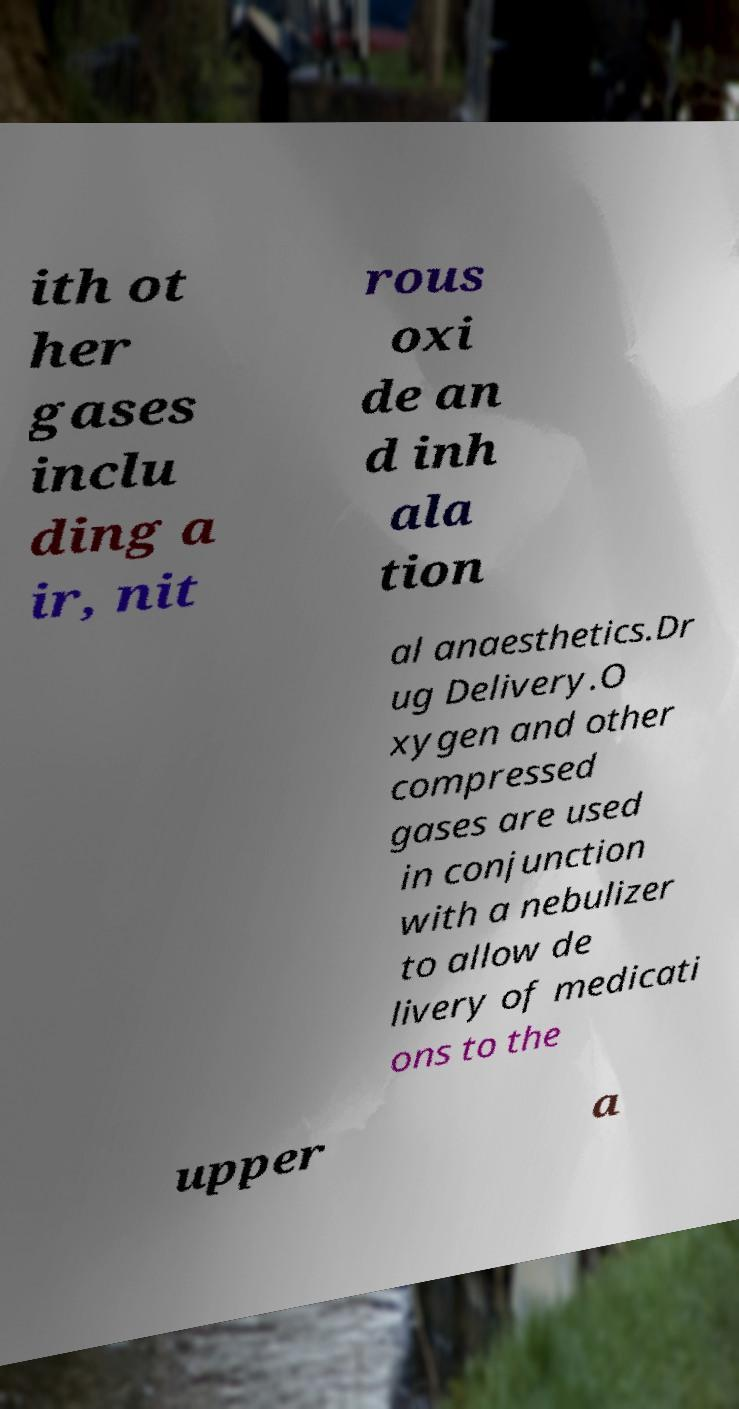Can you accurately transcribe the text from the provided image for me? ith ot her gases inclu ding a ir, nit rous oxi de an d inh ala tion al anaesthetics.Dr ug Delivery.O xygen and other compressed gases are used in conjunction with a nebulizer to allow de livery of medicati ons to the upper a 